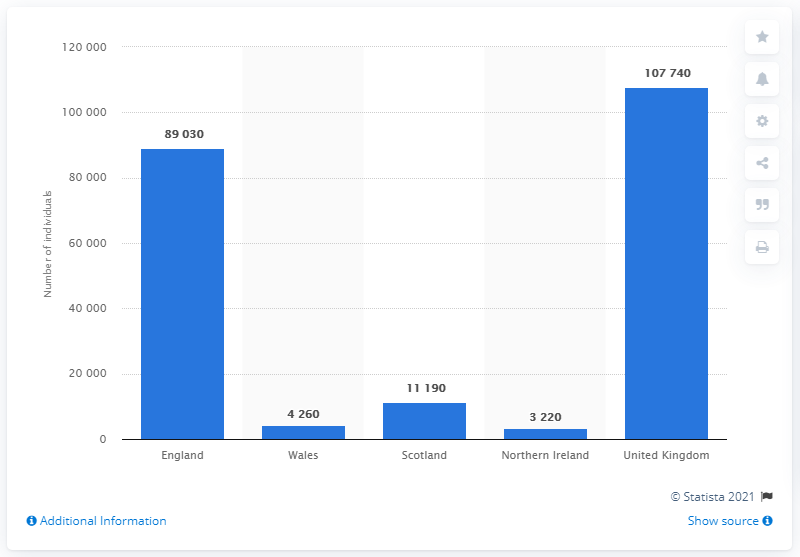Indicate a few pertinent items in this graphic. The United Kingdom leads in this category. The total number of patients in Wales and Northern Ireland is 7480. In 2014, it is estimated that approximately 107,740 people in the United Kingdom were living with multiple sclerosis. 